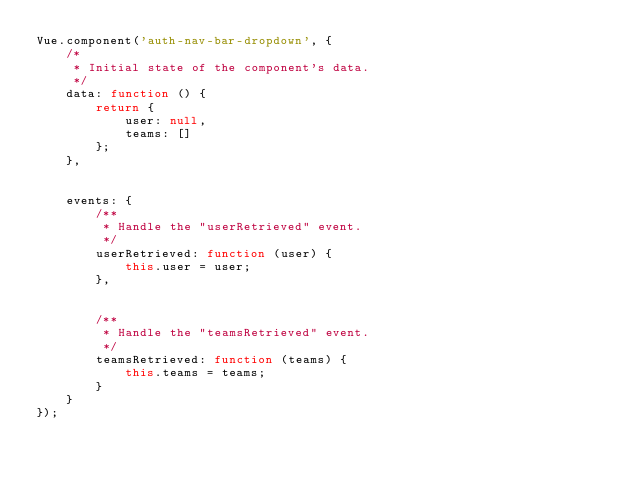Convert code to text. <code><loc_0><loc_0><loc_500><loc_500><_JavaScript_>Vue.component('auth-nav-bar-dropdown', {
    /*
     * Initial state of the component's data.
     */
	data: function () {
		return {
			user: null,
			teams: []
		};
	},


	events: {
        /**
         * Handle the "userRetrieved" event.
         */
		userRetrieved: function (user) {
			this.user = user;
		},


        /**
         * Handle the "teamsRetrieved" event.
         */
		teamsRetrieved: function (teams) {
			this.teams = teams;
		}
	}
});
</code> 